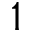Convert formula to latex. <formula><loc_0><loc_0><loc_500><loc_500>1</formula> 